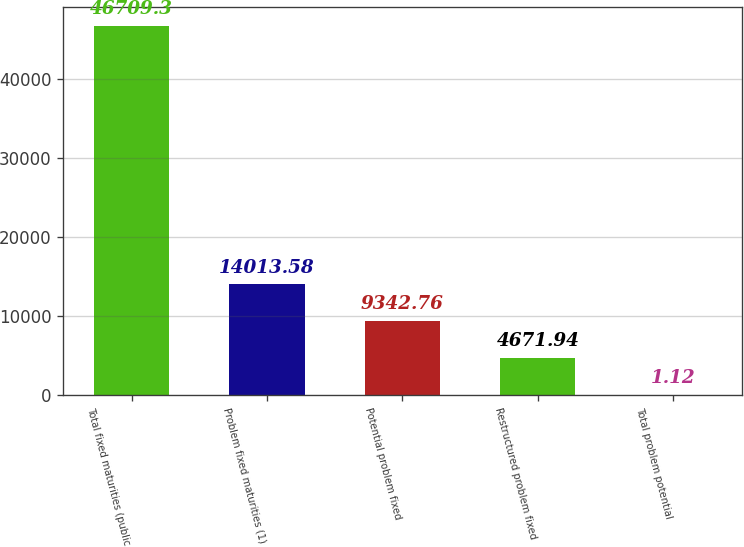Convert chart. <chart><loc_0><loc_0><loc_500><loc_500><bar_chart><fcel>Total fixed maturities (public<fcel>Problem fixed maturities (1)<fcel>Potential problem fixed<fcel>Restructured problem fixed<fcel>Total problem potential<nl><fcel>46709.3<fcel>14013.6<fcel>9342.76<fcel>4671.94<fcel>1.12<nl></chart> 